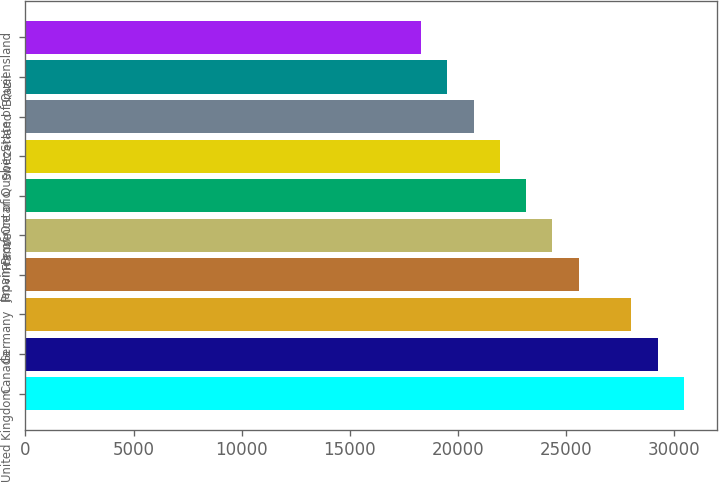Convert chart. <chart><loc_0><loc_0><loc_500><loc_500><bar_chart><fcel>United Kingdom<fcel>Canada<fcel>Germany<fcel>Japan<fcel>France<fcel>Province of Ontario<fcel>Province of Quebec<fcel>Switzerland<fcel>Brazil<fcel>State of Queensland<nl><fcel>30448<fcel>29231.4<fcel>28014.8<fcel>25581.6<fcel>24365<fcel>23148.4<fcel>21931.8<fcel>20715.2<fcel>19498.6<fcel>18282<nl></chart> 